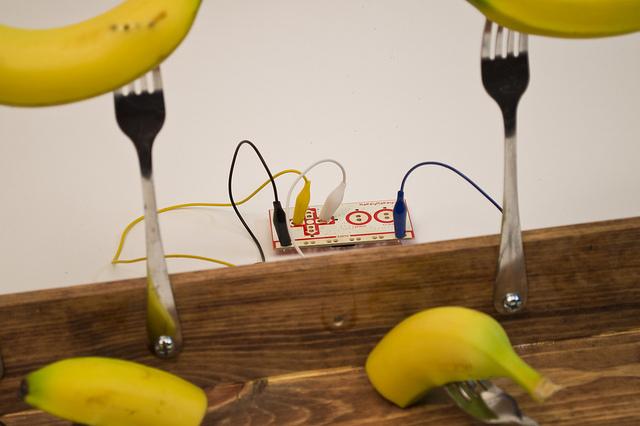How many forks are upright?
Answer briefly. 2. How many pieces of fruit do you see?
Write a very short answer. 4. What fruit is in the picture?
Write a very short answer. Banana. How are the forks attached to the wood?
Concise answer only. Screws. 